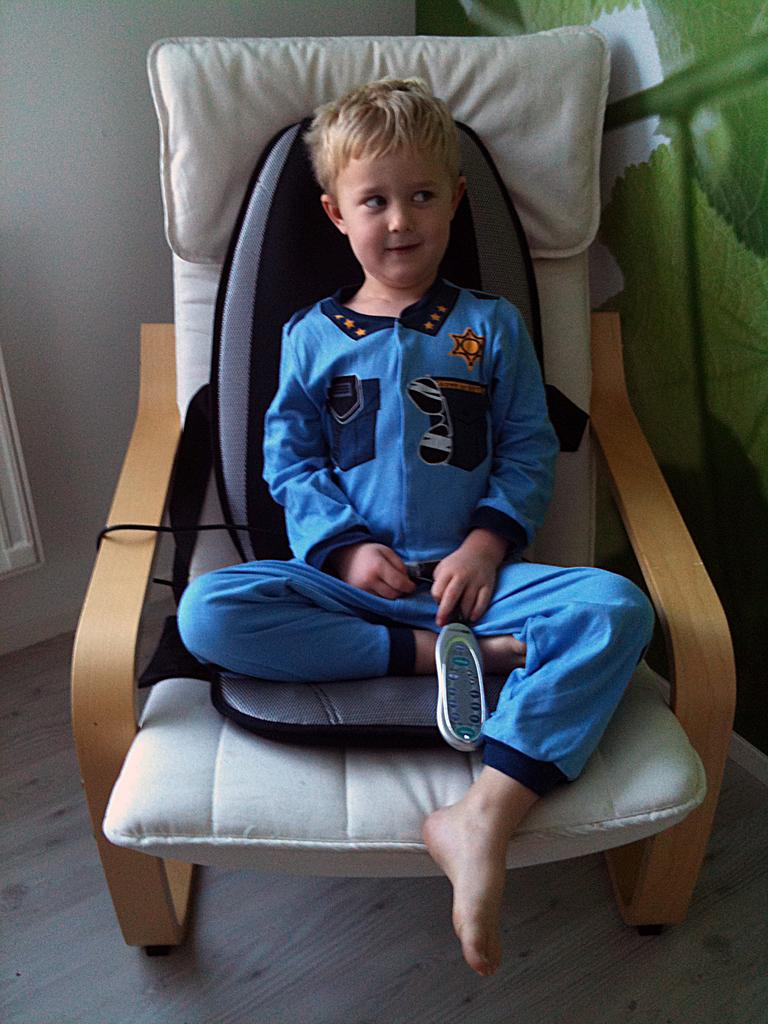What piece of furniture is in the image? There is a chair in the image. Who is sitting on the chair? A kid is sitting on the chair. What is the kid wearing? The kid is wearing a blue dress. What news story is the kid reading from the chair? There is no news story or reading material present in the image. 